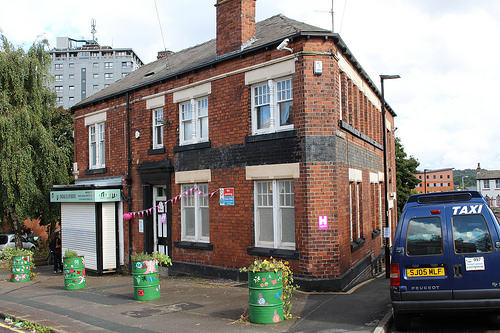<image>
Can you confirm if the taxi is in front of the barrel? No. The taxi is not in front of the barrel. The spatial positioning shows a different relationship between these objects. 